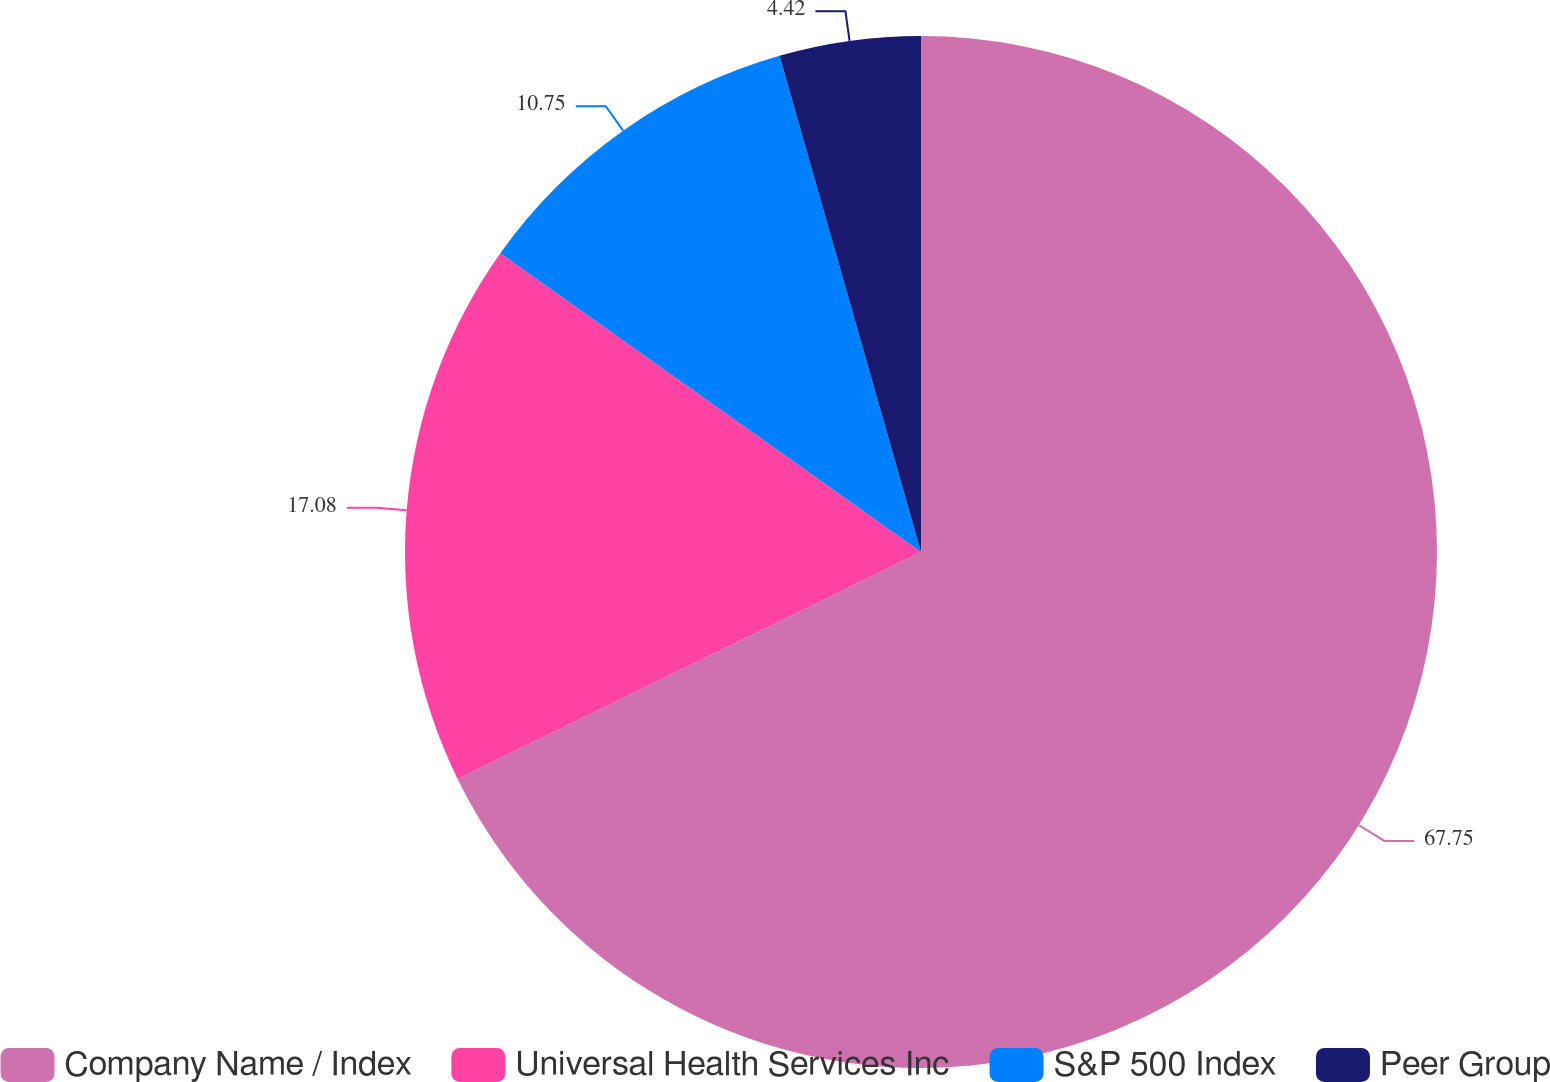Convert chart. <chart><loc_0><loc_0><loc_500><loc_500><pie_chart><fcel>Company Name / Index<fcel>Universal Health Services Inc<fcel>S&P 500 Index<fcel>Peer Group<nl><fcel>67.75%<fcel>17.08%<fcel>10.75%<fcel>4.42%<nl></chart> 